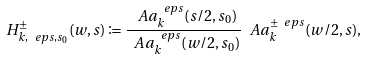<formula> <loc_0><loc_0><loc_500><loc_500>H ^ { \pm } _ { k , \ e p s , s _ { 0 } } ( w , s ) \coloneqq \frac { \ A a ^ { \ e p s } _ { k } ( s / 2 , s _ { 0 } ) } { \ A a ^ { \ e p s } _ { k } ( w / 2 , s _ { 0 } ) } \ A a ^ { \pm \ e p s } _ { k } ( w / 2 , s ) ,</formula> 